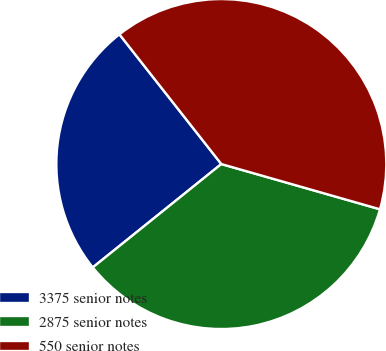<chart> <loc_0><loc_0><loc_500><loc_500><pie_chart><fcel>3375 senior notes<fcel>2875 senior notes<fcel>550 senior notes<nl><fcel>25.18%<fcel>34.8%<fcel>40.02%<nl></chart> 